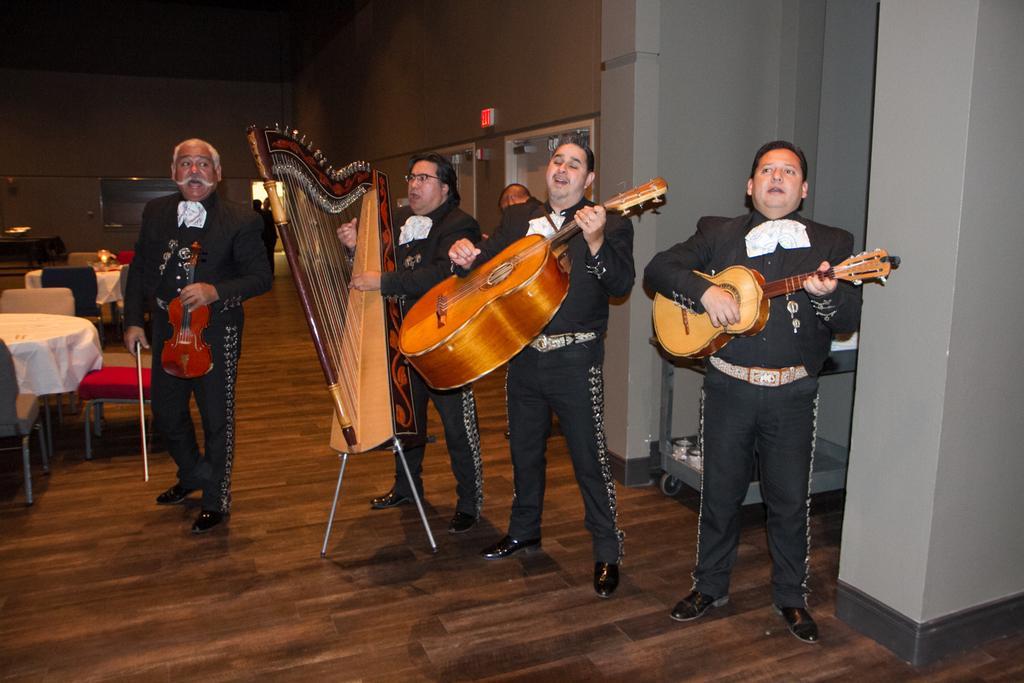How would you summarize this image in a sentence or two? This image is clicked in a room where there are five persons, four of them are playing musical instruments. There are tables on the left and chairs also. 